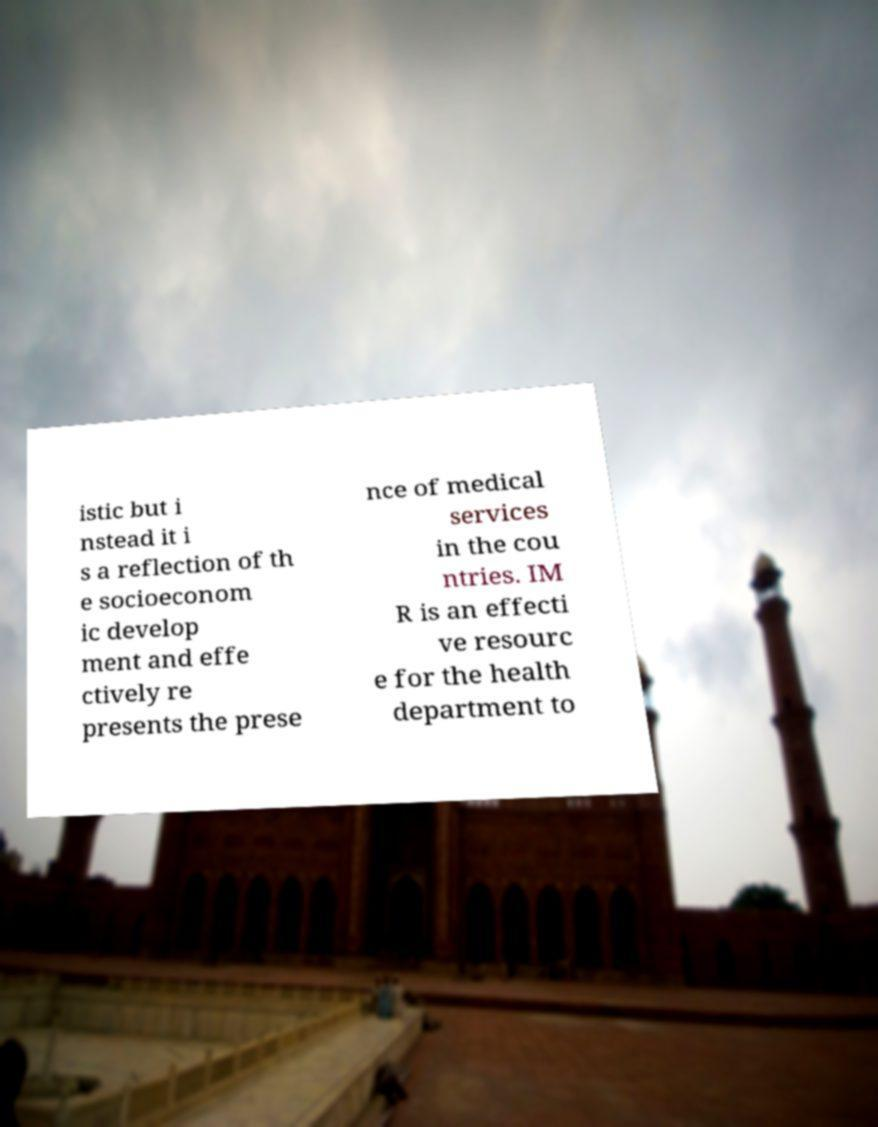What messages or text are displayed in this image? I need them in a readable, typed format. istic but i nstead it i s a reflection of th e socioeconom ic develop ment and effe ctively re presents the prese nce of medical services in the cou ntries. IM R is an effecti ve resourc e for the health department to 